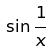<formula> <loc_0><loc_0><loc_500><loc_500>\sin \frac { 1 } { x }</formula> 